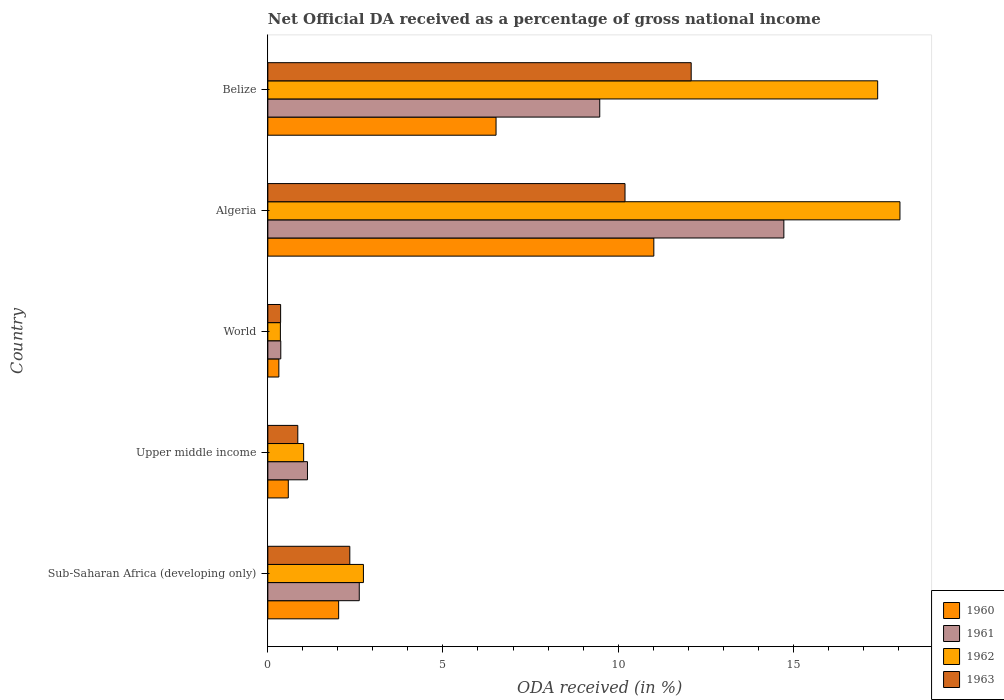How many different coloured bars are there?
Offer a very short reply. 4. How many groups of bars are there?
Provide a short and direct response. 5. Are the number of bars on each tick of the Y-axis equal?
Provide a short and direct response. Yes. How many bars are there on the 1st tick from the top?
Give a very brief answer. 4. What is the label of the 4th group of bars from the top?
Ensure brevity in your answer.  Upper middle income. In how many cases, is the number of bars for a given country not equal to the number of legend labels?
Make the answer very short. 0. What is the net official DA received in 1960 in Belize?
Offer a terse response. 6.52. Across all countries, what is the maximum net official DA received in 1963?
Offer a terse response. 12.09. Across all countries, what is the minimum net official DA received in 1963?
Provide a short and direct response. 0.36. In which country was the net official DA received in 1962 maximum?
Ensure brevity in your answer.  Algeria. In which country was the net official DA received in 1963 minimum?
Provide a short and direct response. World. What is the total net official DA received in 1962 in the graph?
Provide a succinct answer. 39.57. What is the difference between the net official DA received in 1963 in Belize and that in Upper middle income?
Provide a short and direct response. 11.23. What is the difference between the net official DA received in 1960 in World and the net official DA received in 1961 in Algeria?
Offer a terse response. -14.42. What is the average net official DA received in 1963 per country?
Your response must be concise. 5.17. What is the difference between the net official DA received in 1962 and net official DA received in 1961 in Upper middle income?
Ensure brevity in your answer.  -0.11. What is the ratio of the net official DA received in 1960 in Algeria to that in World?
Give a very brief answer. 35.04. What is the difference between the highest and the second highest net official DA received in 1960?
Give a very brief answer. 4.51. What is the difference between the highest and the lowest net official DA received in 1961?
Your answer should be very brief. 14.36. In how many countries, is the net official DA received in 1960 greater than the average net official DA received in 1960 taken over all countries?
Give a very brief answer. 2. Is it the case that in every country, the sum of the net official DA received in 1960 and net official DA received in 1961 is greater than the sum of net official DA received in 1962 and net official DA received in 1963?
Provide a succinct answer. No. What does the 3rd bar from the top in Algeria represents?
Offer a very short reply. 1961. What does the 3rd bar from the bottom in Belize represents?
Offer a very short reply. 1962. How many bars are there?
Provide a short and direct response. 20. Are all the bars in the graph horizontal?
Your response must be concise. Yes. What is the difference between two consecutive major ticks on the X-axis?
Keep it short and to the point. 5. Are the values on the major ticks of X-axis written in scientific E-notation?
Offer a very short reply. No. Does the graph contain grids?
Offer a very short reply. No. How are the legend labels stacked?
Make the answer very short. Vertical. What is the title of the graph?
Give a very brief answer. Net Official DA received as a percentage of gross national income. Does "2005" appear as one of the legend labels in the graph?
Your answer should be very brief. No. What is the label or title of the X-axis?
Give a very brief answer. ODA received (in %). What is the ODA received (in %) in 1960 in Sub-Saharan Africa (developing only)?
Your response must be concise. 2.02. What is the ODA received (in %) of 1961 in Sub-Saharan Africa (developing only)?
Your answer should be very brief. 2.61. What is the ODA received (in %) in 1962 in Sub-Saharan Africa (developing only)?
Give a very brief answer. 2.73. What is the ODA received (in %) of 1963 in Sub-Saharan Africa (developing only)?
Your response must be concise. 2.34. What is the ODA received (in %) of 1960 in Upper middle income?
Provide a succinct answer. 0.58. What is the ODA received (in %) of 1961 in Upper middle income?
Your answer should be compact. 1.13. What is the ODA received (in %) in 1962 in Upper middle income?
Ensure brevity in your answer.  1.02. What is the ODA received (in %) of 1963 in Upper middle income?
Keep it short and to the point. 0.86. What is the ODA received (in %) in 1960 in World?
Provide a short and direct response. 0.31. What is the ODA received (in %) of 1961 in World?
Offer a terse response. 0.37. What is the ODA received (in %) of 1962 in World?
Your response must be concise. 0.36. What is the ODA received (in %) of 1963 in World?
Offer a terse response. 0.36. What is the ODA received (in %) of 1960 in Algeria?
Your answer should be compact. 11.02. What is the ODA received (in %) of 1961 in Algeria?
Offer a terse response. 14.73. What is the ODA received (in %) of 1962 in Algeria?
Offer a terse response. 18.05. What is the ODA received (in %) in 1963 in Algeria?
Keep it short and to the point. 10.2. What is the ODA received (in %) in 1960 in Belize?
Your answer should be very brief. 6.52. What is the ODA received (in %) of 1961 in Belize?
Make the answer very short. 9.48. What is the ODA received (in %) of 1962 in Belize?
Offer a very short reply. 17.41. What is the ODA received (in %) in 1963 in Belize?
Your response must be concise. 12.09. Across all countries, what is the maximum ODA received (in %) in 1960?
Provide a short and direct response. 11.02. Across all countries, what is the maximum ODA received (in %) in 1961?
Your answer should be compact. 14.73. Across all countries, what is the maximum ODA received (in %) in 1962?
Keep it short and to the point. 18.05. Across all countries, what is the maximum ODA received (in %) of 1963?
Make the answer very short. 12.09. Across all countries, what is the minimum ODA received (in %) in 1960?
Provide a succinct answer. 0.31. Across all countries, what is the minimum ODA received (in %) of 1961?
Your response must be concise. 0.37. Across all countries, what is the minimum ODA received (in %) in 1962?
Keep it short and to the point. 0.36. Across all countries, what is the minimum ODA received (in %) of 1963?
Offer a terse response. 0.36. What is the total ODA received (in %) of 1960 in the graph?
Provide a succinct answer. 20.46. What is the total ODA received (in %) of 1961 in the graph?
Your answer should be compact. 28.32. What is the total ODA received (in %) in 1962 in the graph?
Keep it short and to the point. 39.57. What is the total ODA received (in %) in 1963 in the graph?
Provide a succinct answer. 25.85. What is the difference between the ODA received (in %) in 1960 in Sub-Saharan Africa (developing only) and that in Upper middle income?
Your answer should be very brief. 1.44. What is the difference between the ODA received (in %) in 1961 in Sub-Saharan Africa (developing only) and that in Upper middle income?
Make the answer very short. 1.48. What is the difference between the ODA received (in %) in 1962 in Sub-Saharan Africa (developing only) and that in Upper middle income?
Your answer should be very brief. 1.71. What is the difference between the ODA received (in %) in 1963 in Sub-Saharan Africa (developing only) and that in Upper middle income?
Offer a terse response. 1.49. What is the difference between the ODA received (in %) of 1960 in Sub-Saharan Africa (developing only) and that in World?
Offer a very short reply. 1.71. What is the difference between the ODA received (in %) in 1961 in Sub-Saharan Africa (developing only) and that in World?
Your response must be concise. 2.24. What is the difference between the ODA received (in %) in 1962 in Sub-Saharan Africa (developing only) and that in World?
Provide a succinct answer. 2.37. What is the difference between the ODA received (in %) in 1963 in Sub-Saharan Africa (developing only) and that in World?
Make the answer very short. 1.98. What is the difference between the ODA received (in %) in 1960 in Sub-Saharan Africa (developing only) and that in Algeria?
Your response must be concise. -9. What is the difference between the ODA received (in %) of 1961 in Sub-Saharan Africa (developing only) and that in Algeria?
Your response must be concise. -12.12. What is the difference between the ODA received (in %) in 1962 in Sub-Saharan Africa (developing only) and that in Algeria?
Offer a terse response. -15.32. What is the difference between the ODA received (in %) of 1963 in Sub-Saharan Africa (developing only) and that in Algeria?
Your response must be concise. -7.86. What is the difference between the ODA received (in %) in 1960 in Sub-Saharan Africa (developing only) and that in Belize?
Provide a succinct answer. -4.49. What is the difference between the ODA received (in %) of 1961 in Sub-Saharan Africa (developing only) and that in Belize?
Provide a succinct answer. -6.87. What is the difference between the ODA received (in %) in 1962 in Sub-Saharan Africa (developing only) and that in Belize?
Keep it short and to the point. -14.68. What is the difference between the ODA received (in %) of 1963 in Sub-Saharan Africa (developing only) and that in Belize?
Keep it short and to the point. -9.75. What is the difference between the ODA received (in %) in 1960 in Upper middle income and that in World?
Your answer should be very brief. 0.27. What is the difference between the ODA received (in %) in 1961 in Upper middle income and that in World?
Offer a terse response. 0.76. What is the difference between the ODA received (in %) in 1962 in Upper middle income and that in World?
Offer a terse response. 0.66. What is the difference between the ODA received (in %) in 1963 in Upper middle income and that in World?
Provide a short and direct response. 0.49. What is the difference between the ODA received (in %) of 1960 in Upper middle income and that in Algeria?
Give a very brief answer. -10.44. What is the difference between the ODA received (in %) of 1961 in Upper middle income and that in Algeria?
Your answer should be very brief. -13.6. What is the difference between the ODA received (in %) in 1962 in Upper middle income and that in Algeria?
Offer a terse response. -17.03. What is the difference between the ODA received (in %) of 1963 in Upper middle income and that in Algeria?
Your answer should be very brief. -9.34. What is the difference between the ODA received (in %) of 1960 in Upper middle income and that in Belize?
Provide a succinct answer. -5.93. What is the difference between the ODA received (in %) of 1961 in Upper middle income and that in Belize?
Keep it short and to the point. -8.35. What is the difference between the ODA received (in %) of 1962 in Upper middle income and that in Belize?
Your answer should be compact. -16.39. What is the difference between the ODA received (in %) in 1963 in Upper middle income and that in Belize?
Give a very brief answer. -11.23. What is the difference between the ODA received (in %) in 1960 in World and that in Algeria?
Your answer should be very brief. -10.71. What is the difference between the ODA received (in %) in 1961 in World and that in Algeria?
Offer a very short reply. -14.36. What is the difference between the ODA received (in %) in 1962 in World and that in Algeria?
Offer a very short reply. -17.69. What is the difference between the ODA received (in %) in 1963 in World and that in Algeria?
Provide a succinct answer. -9.83. What is the difference between the ODA received (in %) in 1960 in World and that in Belize?
Your answer should be very brief. -6.2. What is the difference between the ODA received (in %) of 1961 in World and that in Belize?
Make the answer very short. -9.11. What is the difference between the ODA received (in %) of 1962 in World and that in Belize?
Offer a very short reply. -17.05. What is the difference between the ODA received (in %) of 1963 in World and that in Belize?
Provide a short and direct response. -11.72. What is the difference between the ODA received (in %) of 1960 in Algeria and that in Belize?
Make the answer very short. 4.51. What is the difference between the ODA received (in %) in 1961 in Algeria and that in Belize?
Ensure brevity in your answer.  5.26. What is the difference between the ODA received (in %) in 1962 in Algeria and that in Belize?
Your response must be concise. 0.64. What is the difference between the ODA received (in %) of 1963 in Algeria and that in Belize?
Offer a terse response. -1.89. What is the difference between the ODA received (in %) in 1960 in Sub-Saharan Africa (developing only) and the ODA received (in %) in 1961 in Upper middle income?
Provide a succinct answer. 0.89. What is the difference between the ODA received (in %) in 1960 in Sub-Saharan Africa (developing only) and the ODA received (in %) in 1962 in Upper middle income?
Offer a very short reply. 1. What is the difference between the ODA received (in %) of 1960 in Sub-Saharan Africa (developing only) and the ODA received (in %) of 1963 in Upper middle income?
Your response must be concise. 1.17. What is the difference between the ODA received (in %) in 1961 in Sub-Saharan Africa (developing only) and the ODA received (in %) in 1962 in Upper middle income?
Offer a terse response. 1.59. What is the difference between the ODA received (in %) in 1961 in Sub-Saharan Africa (developing only) and the ODA received (in %) in 1963 in Upper middle income?
Give a very brief answer. 1.75. What is the difference between the ODA received (in %) of 1962 in Sub-Saharan Africa (developing only) and the ODA received (in %) of 1963 in Upper middle income?
Keep it short and to the point. 1.87. What is the difference between the ODA received (in %) of 1960 in Sub-Saharan Africa (developing only) and the ODA received (in %) of 1961 in World?
Provide a short and direct response. 1.65. What is the difference between the ODA received (in %) in 1960 in Sub-Saharan Africa (developing only) and the ODA received (in %) in 1962 in World?
Your answer should be very brief. 1.66. What is the difference between the ODA received (in %) in 1960 in Sub-Saharan Africa (developing only) and the ODA received (in %) in 1963 in World?
Keep it short and to the point. 1.66. What is the difference between the ODA received (in %) in 1961 in Sub-Saharan Africa (developing only) and the ODA received (in %) in 1962 in World?
Provide a short and direct response. 2.25. What is the difference between the ODA received (in %) of 1961 in Sub-Saharan Africa (developing only) and the ODA received (in %) of 1963 in World?
Give a very brief answer. 2.25. What is the difference between the ODA received (in %) in 1962 in Sub-Saharan Africa (developing only) and the ODA received (in %) in 1963 in World?
Offer a very short reply. 2.36. What is the difference between the ODA received (in %) in 1960 in Sub-Saharan Africa (developing only) and the ODA received (in %) in 1961 in Algeria?
Your answer should be very brief. -12.71. What is the difference between the ODA received (in %) in 1960 in Sub-Saharan Africa (developing only) and the ODA received (in %) in 1962 in Algeria?
Provide a succinct answer. -16.03. What is the difference between the ODA received (in %) of 1960 in Sub-Saharan Africa (developing only) and the ODA received (in %) of 1963 in Algeria?
Provide a short and direct response. -8.18. What is the difference between the ODA received (in %) of 1961 in Sub-Saharan Africa (developing only) and the ODA received (in %) of 1962 in Algeria?
Give a very brief answer. -15.44. What is the difference between the ODA received (in %) of 1961 in Sub-Saharan Africa (developing only) and the ODA received (in %) of 1963 in Algeria?
Your answer should be compact. -7.59. What is the difference between the ODA received (in %) of 1962 in Sub-Saharan Africa (developing only) and the ODA received (in %) of 1963 in Algeria?
Give a very brief answer. -7.47. What is the difference between the ODA received (in %) of 1960 in Sub-Saharan Africa (developing only) and the ODA received (in %) of 1961 in Belize?
Provide a short and direct response. -7.46. What is the difference between the ODA received (in %) in 1960 in Sub-Saharan Africa (developing only) and the ODA received (in %) in 1962 in Belize?
Offer a very short reply. -15.39. What is the difference between the ODA received (in %) in 1960 in Sub-Saharan Africa (developing only) and the ODA received (in %) in 1963 in Belize?
Keep it short and to the point. -10.07. What is the difference between the ODA received (in %) in 1961 in Sub-Saharan Africa (developing only) and the ODA received (in %) in 1962 in Belize?
Your answer should be very brief. -14.8. What is the difference between the ODA received (in %) of 1961 in Sub-Saharan Africa (developing only) and the ODA received (in %) of 1963 in Belize?
Provide a succinct answer. -9.48. What is the difference between the ODA received (in %) in 1962 in Sub-Saharan Africa (developing only) and the ODA received (in %) in 1963 in Belize?
Your answer should be very brief. -9.36. What is the difference between the ODA received (in %) in 1960 in Upper middle income and the ODA received (in %) in 1961 in World?
Provide a short and direct response. 0.21. What is the difference between the ODA received (in %) of 1960 in Upper middle income and the ODA received (in %) of 1962 in World?
Your answer should be compact. 0.23. What is the difference between the ODA received (in %) in 1960 in Upper middle income and the ODA received (in %) in 1963 in World?
Provide a short and direct response. 0.22. What is the difference between the ODA received (in %) in 1961 in Upper middle income and the ODA received (in %) in 1962 in World?
Ensure brevity in your answer.  0.77. What is the difference between the ODA received (in %) in 1961 in Upper middle income and the ODA received (in %) in 1963 in World?
Give a very brief answer. 0.77. What is the difference between the ODA received (in %) of 1962 in Upper middle income and the ODA received (in %) of 1963 in World?
Your answer should be very brief. 0.66. What is the difference between the ODA received (in %) in 1960 in Upper middle income and the ODA received (in %) in 1961 in Algeria?
Offer a very short reply. -14.15. What is the difference between the ODA received (in %) in 1960 in Upper middle income and the ODA received (in %) in 1962 in Algeria?
Provide a succinct answer. -17.46. What is the difference between the ODA received (in %) of 1960 in Upper middle income and the ODA received (in %) of 1963 in Algeria?
Provide a succinct answer. -9.61. What is the difference between the ODA received (in %) of 1961 in Upper middle income and the ODA received (in %) of 1962 in Algeria?
Your response must be concise. -16.92. What is the difference between the ODA received (in %) in 1961 in Upper middle income and the ODA received (in %) in 1963 in Algeria?
Your response must be concise. -9.07. What is the difference between the ODA received (in %) of 1962 in Upper middle income and the ODA received (in %) of 1963 in Algeria?
Offer a terse response. -9.18. What is the difference between the ODA received (in %) in 1960 in Upper middle income and the ODA received (in %) in 1961 in Belize?
Your answer should be very brief. -8.89. What is the difference between the ODA received (in %) of 1960 in Upper middle income and the ODA received (in %) of 1962 in Belize?
Offer a very short reply. -16.83. What is the difference between the ODA received (in %) in 1960 in Upper middle income and the ODA received (in %) in 1963 in Belize?
Ensure brevity in your answer.  -11.5. What is the difference between the ODA received (in %) in 1961 in Upper middle income and the ODA received (in %) in 1962 in Belize?
Make the answer very short. -16.28. What is the difference between the ODA received (in %) in 1961 in Upper middle income and the ODA received (in %) in 1963 in Belize?
Give a very brief answer. -10.96. What is the difference between the ODA received (in %) of 1962 in Upper middle income and the ODA received (in %) of 1963 in Belize?
Give a very brief answer. -11.07. What is the difference between the ODA received (in %) in 1960 in World and the ODA received (in %) in 1961 in Algeria?
Give a very brief answer. -14.42. What is the difference between the ODA received (in %) in 1960 in World and the ODA received (in %) in 1962 in Algeria?
Offer a very short reply. -17.73. What is the difference between the ODA received (in %) in 1960 in World and the ODA received (in %) in 1963 in Algeria?
Your answer should be very brief. -9.88. What is the difference between the ODA received (in %) in 1961 in World and the ODA received (in %) in 1962 in Algeria?
Provide a succinct answer. -17.68. What is the difference between the ODA received (in %) of 1961 in World and the ODA received (in %) of 1963 in Algeria?
Provide a succinct answer. -9.83. What is the difference between the ODA received (in %) of 1962 in World and the ODA received (in %) of 1963 in Algeria?
Offer a very short reply. -9.84. What is the difference between the ODA received (in %) in 1960 in World and the ODA received (in %) in 1961 in Belize?
Keep it short and to the point. -9.16. What is the difference between the ODA received (in %) of 1960 in World and the ODA received (in %) of 1962 in Belize?
Your answer should be compact. -17.1. What is the difference between the ODA received (in %) in 1960 in World and the ODA received (in %) in 1963 in Belize?
Provide a short and direct response. -11.77. What is the difference between the ODA received (in %) of 1961 in World and the ODA received (in %) of 1962 in Belize?
Give a very brief answer. -17.04. What is the difference between the ODA received (in %) of 1961 in World and the ODA received (in %) of 1963 in Belize?
Provide a short and direct response. -11.72. What is the difference between the ODA received (in %) of 1962 in World and the ODA received (in %) of 1963 in Belize?
Provide a short and direct response. -11.73. What is the difference between the ODA received (in %) of 1960 in Algeria and the ODA received (in %) of 1961 in Belize?
Ensure brevity in your answer.  1.54. What is the difference between the ODA received (in %) in 1960 in Algeria and the ODA received (in %) in 1962 in Belize?
Offer a terse response. -6.39. What is the difference between the ODA received (in %) of 1960 in Algeria and the ODA received (in %) of 1963 in Belize?
Your answer should be compact. -1.07. What is the difference between the ODA received (in %) in 1961 in Algeria and the ODA received (in %) in 1962 in Belize?
Provide a short and direct response. -2.68. What is the difference between the ODA received (in %) in 1961 in Algeria and the ODA received (in %) in 1963 in Belize?
Offer a terse response. 2.65. What is the difference between the ODA received (in %) of 1962 in Algeria and the ODA received (in %) of 1963 in Belize?
Your answer should be compact. 5.96. What is the average ODA received (in %) in 1960 per country?
Give a very brief answer. 4.09. What is the average ODA received (in %) in 1961 per country?
Make the answer very short. 5.66. What is the average ODA received (in %) of 1962 per country?
Your response must be concise. 7.91. What is the average ODA received (in %) in 1963 per country?
Your answer should be very brief. 5.17. What is the difference between the ODA received (in %) in 1960 and ODA received (in %) in 1961 in Sub-Saharan Africa (developing only)?
Your response must be concise. -0.59. What is the difference between the ODA received (in %) of 1960 and ODA received (in %) of 1962 in Sub-Saharan Africa (developing only)?
Provide a succinct answer. -0.71. What is the difference between the ODA received (in %) in 1960 and ODA received (in %) in 1963 in Sub-Saharan Africa (developing only)?
Ensure brevity in your answer.  -0.32. What is the difference between the ODA received (in %) in 1961 and ODA received (in %) in 1962 in Sub-Saharan Africa (developing only)?
Keep it short and to the point. -0.12. What is the difference between the ODA received (in %) of 1961 and ODA received (in %) of 1963 in Sub-Saharan Africa (developing only)?
Your answer should be compact. 0.27. What is the difference between the ODA received (in %) of 1962 and ODA received (in %) of 1963 in Sub-Saharan Africa (developing only)?
Make the answer very short. 0.39. What is the difference between the ODA received (in %) of 1960 and ODA received (in %) of 1961 in Upper middle income?
Provide a short and direct response. -0.55. What is the difference between the ODA received (in %) in 1960 and ODA received (in %) in 1962 in Upper middle income?
Keep it short and to the point. -0.44. What is the difference between the ODA received (in %) in 1960 and ODA received (in %) in 1963 in Upper middle income?
Provide a succinct answer. -0.27. What is the difference between the ODA received (in %) in 1961 and ODA received (in %) in 1962 in Upper middle income?
Your answer should be compact. 0.11. What is the difference between the ODA received (in %) of 1961 and ODA received (in %) of 1963 in Upper middle income?
Keep it short and to the point. 0.28. What is the difference between the ODA received (in %) in 1962 and ODA received (in %) in 1963 in Upper middle income?
Keep it short and to the point. 0.17. What is the difference between the ODA received (in %) of 1960 and ODA received (in %) of 1961 in World?
Your answer should be very brief. -0.06. What is the difference between the ODA received (in %) of 1960 and ODA received (in %) of 1962 in World?
Ensure brevity in your answer.  -0.04. What is the difference between the ODA received (in %) of 1960 and ODA received (in %) of 1963 in World?
Provide a short and direct response. -0.05. What is the difference between the ODA received (in %) of 1961 and ODA received (in %) of 1962 in World?
Provide a short and direct response. 0.01. What is the difference between the ODA received (in %) in 1961 and ODA received (in %) in 1963 in World?
Offer a very short reply. 0. What is the difference between the ODA received (in %) in 1962 and ODA received (in %) in 1963 in World?
Your response must be concise. -0.01. What is the difference between the ODA received (in %) in 1960 and ODA received (in %) in 1961 in Algeria?
Your answer should be compact. -3.71. What is the difference between the ODA received (in %) in 1960 and ODA received (in %) in 1962 in Algeria?
Give a very brief answer. -7.03. What is the difference between the ODA received (in %) of 1960 and ODA received (in %) of 1963 in Algeria?
Provide a succinct answer. 0.82. What is the difference between the ODA received (in %) of 1961 and ODA received (in %) of 1962 in Algeria?
Provide a short and direct response. -3.31. What is the difference between the ODA received (in %) of 1961 and ODA received (in %) of 1963 in Algeria?
Offer a terse response. 4.54. What is the difference between the ODA received (in %) in 1962 and ODA received (in %) in 1963 in Algeria?
Keep it short and to the point. 7.85. What is the difference between the ODA received (in %) in 1960 and ODA received (in %) in 1961 in Belize?
Ensure brevity in your answer.  -2.96. What is the difference between the ODA received (in %) in 1960 and ODA received (in %) in 1962 in Belize?
Give a very brief answer. -10.9. What is the difference between the ODA received (in %) in 1960 and ODA received (in %) in 1963 in Belize?
Give a very brief answer. -5.57. What is the difference between the ODA received (in %) in 1961 and ODA received (in %) in 1962 in Belize?
Provide a short and direct response. -7.93. What is the difference between the ODA received (in %) of 1961 and ODA received (in %) of 1963 in Belize?
Keep it short and to the point. -2.61. What is the difference between the ODA received (in %) in 1962 and ODA received (in %) in 1963 in Belize?
Ensure brevity in your answer.  5.32. What is the ratio of the ODA received (in %) of 1960 in Sub-Saharan Africa (developing only) to that in Upper middle income?
Make the answer very short. 3.46. What is the ratio of the ODA received (in %) in 1961 in Sub-Saharan Africa (developing only) to that in Upper middle income?
Your answer should be very brief. 2.31. What is the ratio of the ODA received (in %) in 1962 in Sub-Saharan Africa (developing only) to that in Upper middle income?
Provide a short and direct response. 2.67. What is the ratio of the ODA received (in %) in 1963 in Sub-Saharan Africa (developing only) to that in Upper middle income?
Make the answer very short. 2.74. What is the ratio of the ODA received (in %) of 1960 in Sub-Saharan Africa (developing only) to that in World?
Your answer should be very brief. 6.43. What is the ratio of the ODA received (in %) of 1961 in Sub-Saharan Africa (developing only) to that in World?
Offer a terse response. 7.06. What is the ratio of the ODA received (in %) in 1962 in Sub-Saharan Africa (developing only) to that in World?
Keep it short and to the point. 7.62. What is the ratio of the ODA received (in %) in 1963 in Sub-Saharan Africa (developing only) to that in World?
Make the answer very short. 6.42. What is the ratio of the ODA received (in %) of 1960 in Sub-Saharan Africa (developing only) to that in Algeria?
Your answer should be compact. 0.18. What is the ratio of the ODA received (in %) of 1961 in Sub-Saharan Africa (developing only) to that in Algeria?
Keep it short and to the point. 0.18. What is the ratio of the ODA received (in %) in 1962 in Sub-Saharan Africa (developing only) to that in Algeria?
Ensure brevity in your answer.  0.15. What is the ratio of the ODA received (in %) in 1963 in Sub-Saharan Africa (developing only) to that in Algeria?
Provide a short and direct response. 0.23. What is the ratio of the ODA received (in %) of 1960 in Sub-Saharan Africa (developing only) to that in Belize?
Your answer should be very brief. 0.31. What is the ratio of the ODA received (in %) of 1961 in Sub-Saharan Africa (developing only) to that in Belize?
Your answer should be very brief. 0.28. What is the ratio of the ODA received (in %) of 1962 in Sub-Saharan Africa (developing only) to that in Belize?
Give a very brief answer. 0.16. What is the ratio of the ODA received (in %) of 1963 in Sub-Saharan Africa (developing only) to that in Belize?
Provide a short and direct response. 0.19. What is the ratio of the ODA received (in %) of 1960 in Upper middle income to that in World?
Ensure brevity in your answer.  1.86. What is the ratio of the ODA received (in %) in 1961 in Upper middle income to that in World?
Make the answer very short. 3.06. What is the ratio of the ODA received (in %) in 1962 in Upper middle income to that in World?
Offer a very short reply. 2.85. What is the ratio of the ODA received (in %) of 1963 in Upper middle income to that in World?
Keep it short and to the point. 2.34. What is the ratio of the ODA received (in %) of 1960 in Upper middle income to that in Algeria?
Give a very brief answer. 0.05. What is the ratio of the ODA received (in %) in 1961 in Upper middle income to that in Algeria?
Provide a short and direct response. 0.08. What is the ratio of the ODA received (in %) of 1962 in Upper middle income to that in Algeria?
Keep it short and to the point. 0.06. What is the ratio of the ODA received (in %) of 1963 in Upper middle income to that in Algeria?
Offer a terse response. 0.08. What is the ratio of the ODA received (in %) in 1960 in Upper middle income to that in Belize?
Keep it short and to the point. 0.09. What is the ratio of the ODA received (in %) of 1961 in Upper middle income to that in Belize?
Make the answer very short. 0.12. What is the ratio of the ODA received (in %) of 1962 in Upper middle income to that in Belize?
Provide a succinct answer. 0.06. What is the ratio of the ODA received (in %) in 1963 in Upper middle income to that in Belize?
Make the answer very short. 0.07. What is the ratio of the ODA received (in %) in 1960 in World to that in Algeria?
Give a very brief answer. 0.03. What is the ratio of the ODA received (in %) of 1961 in World to that in Algeria?
Provide a short and direct response. 0.03. What is the ratio of the ODA received (in %) of 1962 in World to that in Algeria?
Provide a short and direct response. 0.02. What is the ratio of the ODA received (in %) in 1963 in World to that in Algeria?
Ensure brevity in your answer.  0.04. What is the ratio of the ODA received (in %) of 1960 in World to that in Belize?
Ensure brevity in your answer.  0.05. What is the ratio of the ODA received (in %) in 1961 in World to that in Belize?
Give a very brief answer. 0.04. What is the ratio of the ODA received (in %) in 1962 in World to that in Belize?
Keep it short and to the point. 0.02. What is the ratio of the ODA received (in %) in 1963 in World to that in Belize?
Provide a succinct answer. 0.03. What is the ratio of the ODA received (in %) in 1960 in Algeria to that in Belize?
Offer a terse response. 1.69. What is the ratio of the ODA received (in %) of 1961 in Algeria to that in Belize?
Your response must be concise. 1.55. What is the ratio of the ODA received (in %) of 1962 in Algeria to that in Belize?
Keep it short and to the point. 1.04. What is the ratio of the ODA received (in %) in 1963 in Algeria to that in Belize?
Keep it short and to the point. 0.84. What is the difference between the highest and the second highest ODA received (in %) of 1960?
Your response must be concise. 4.51. What is the difference between the highest and the second highest ODA received (in %) of 1961?
Provide a succinct answer. 5.26. What is the difference between the highest and the second highest ODA received (in %) in 1962?
Ensure brevity in your answer.  0.64. What is the difference between the highest and the second highest ODA received (in %) in 1963?
Your answer should be very brief. 1.89. What is the difference between the highest and the lowest ODA received (in %) of 1960?
Provide a short and direct response. 10.71. What is the difference between the highest and the lowest ODA received (in %) in 1961?
Offer a terse response. 14.36. What is the difference between the highest and the lowest ODA received (in %) in 1962?
Your answer should be compact. 17.69. What is the difference between the highest and the lowest ODA received (in %) of 1963?
Make the answer very short. 11.72. 